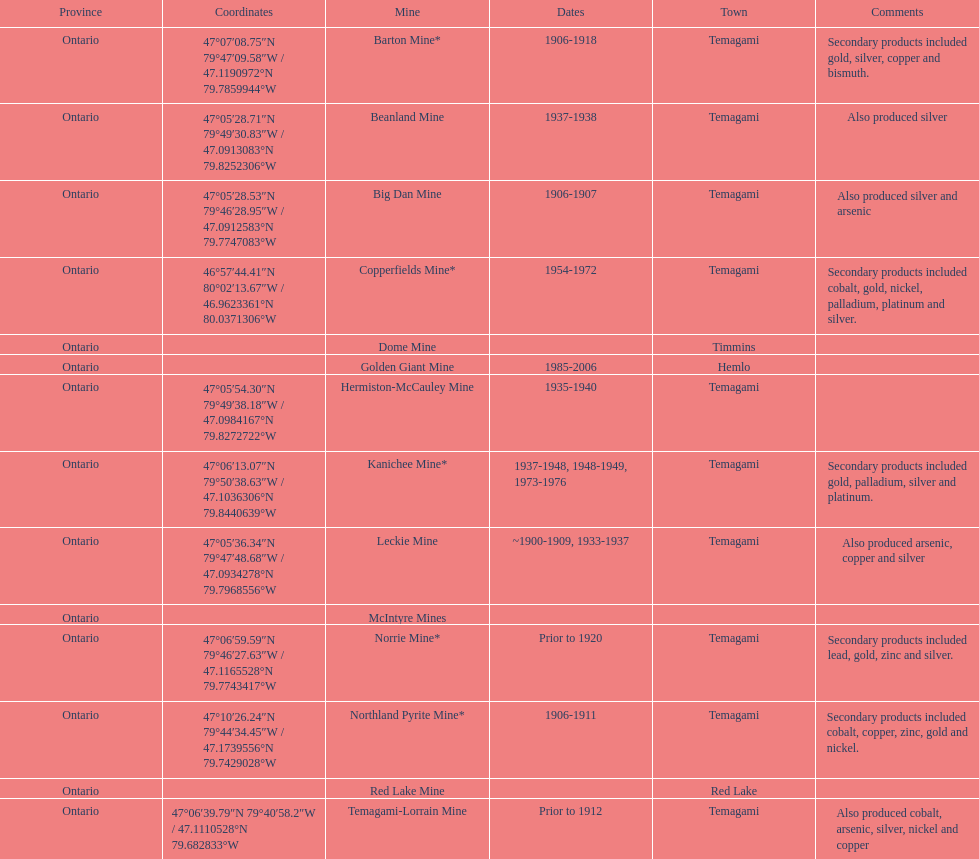Which town is referred to the most? Temagami. 